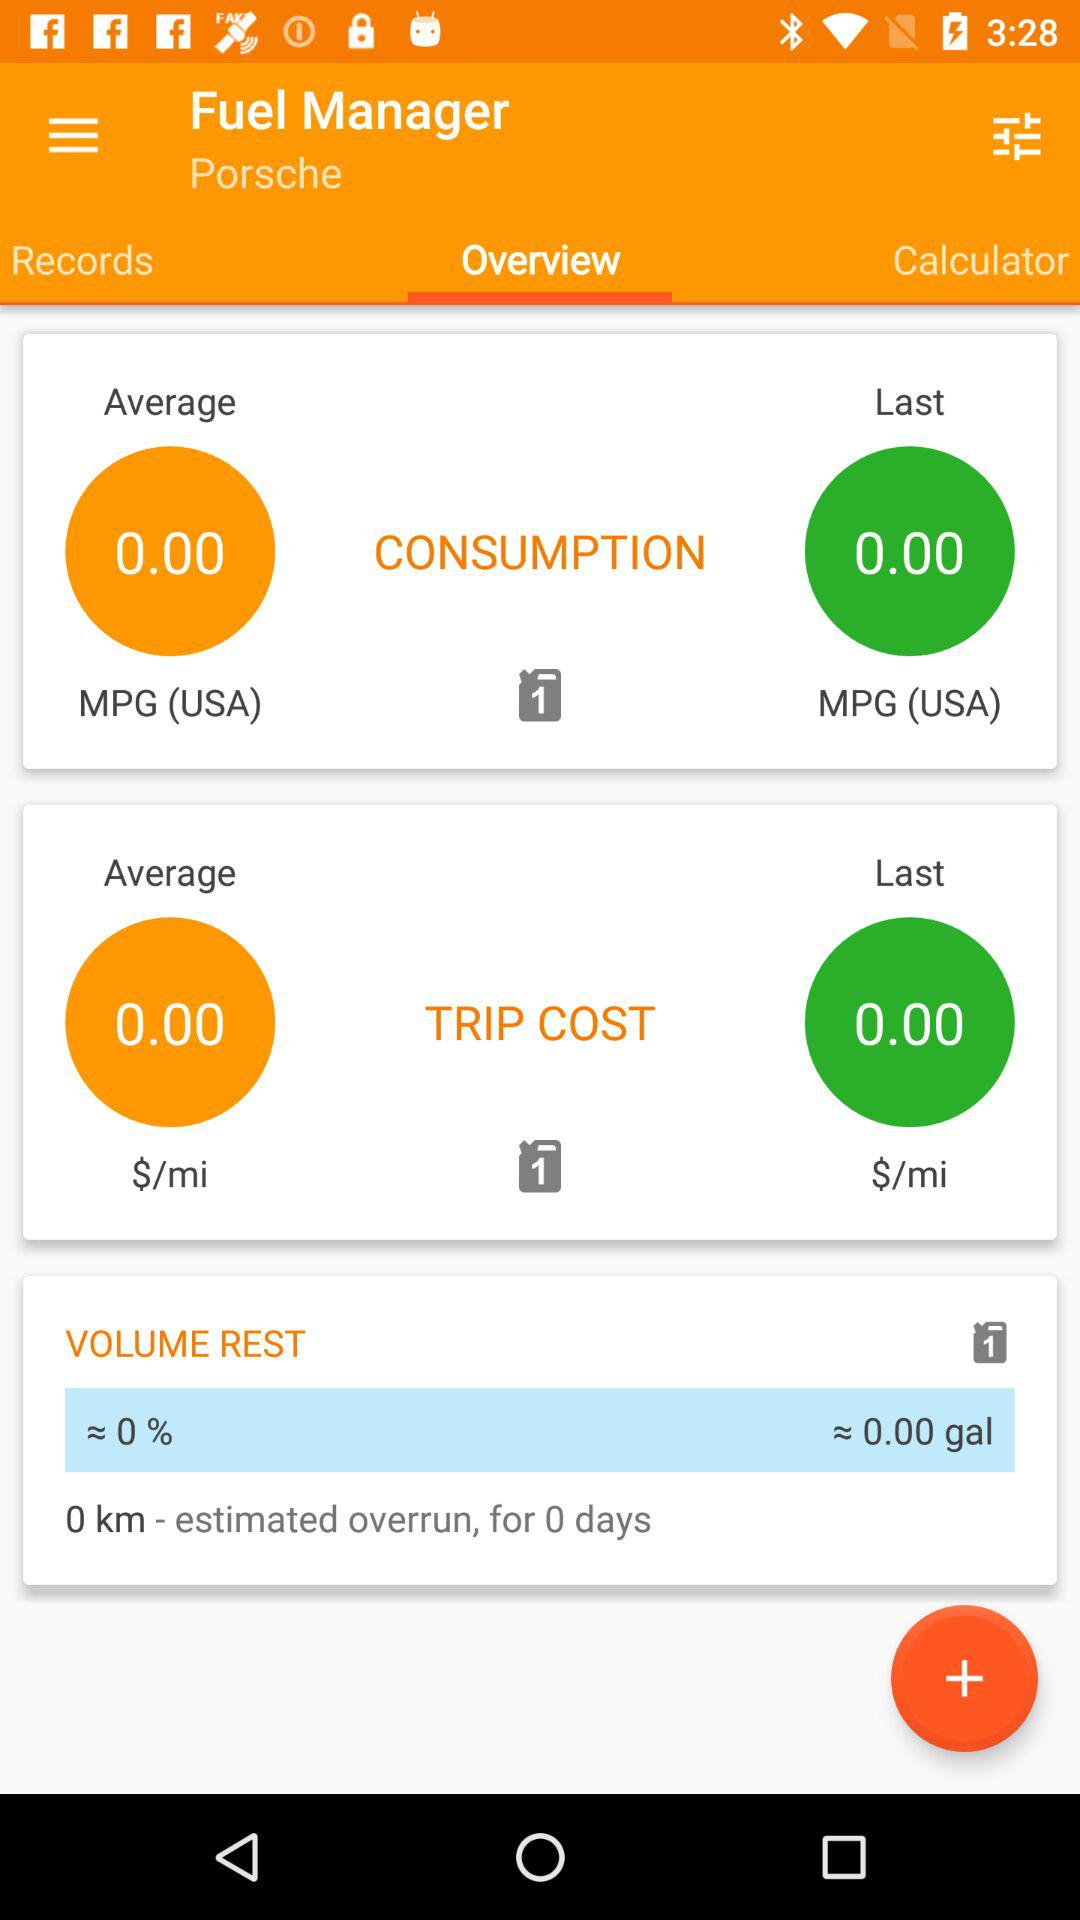What is the estimated overrun in kilometers?
Answer the question using a single word or phrase. 0 km 